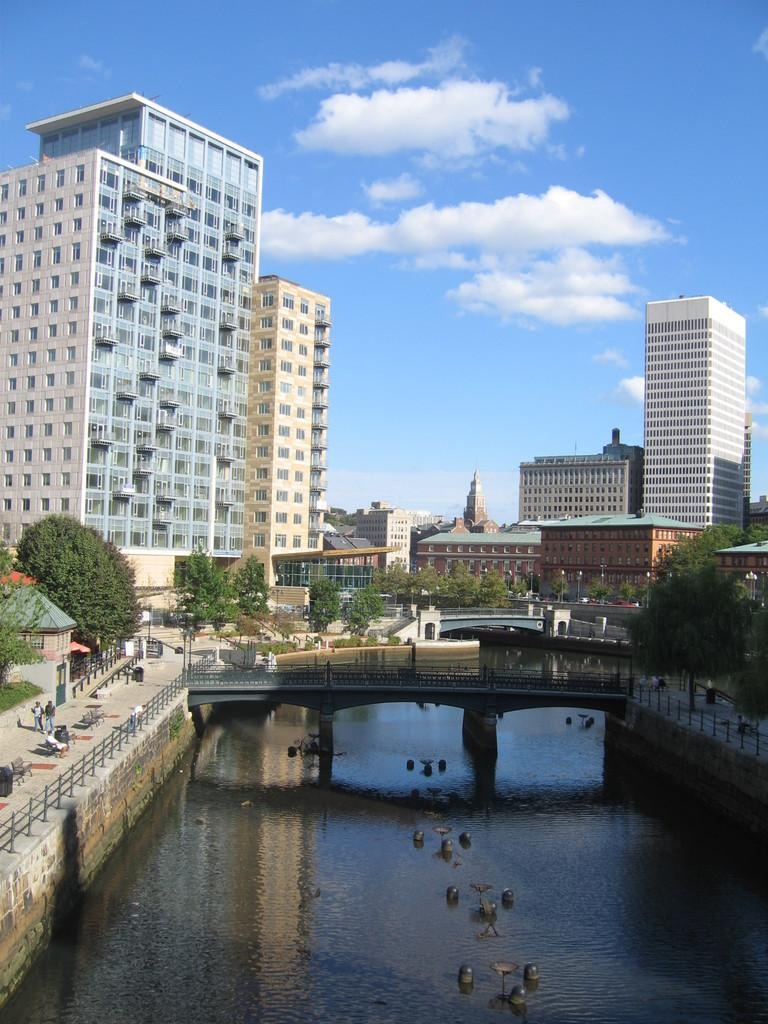What is the main feature of the image? There is water in the image. What is built over the water? There is a bridge over the water. What type of natural elements can be seen in the image? There are trees visible in the image. What type of man-made structures can be seen in the image? There are buildings in the image. What is the manager's role in the image? There is no manager present in the image. How many teeth can be seen in the image? There are no teeth visible in the image. 